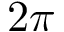<formula> <loc_0><loc_0><loc_500><loc_500>2 \pi</formula> 